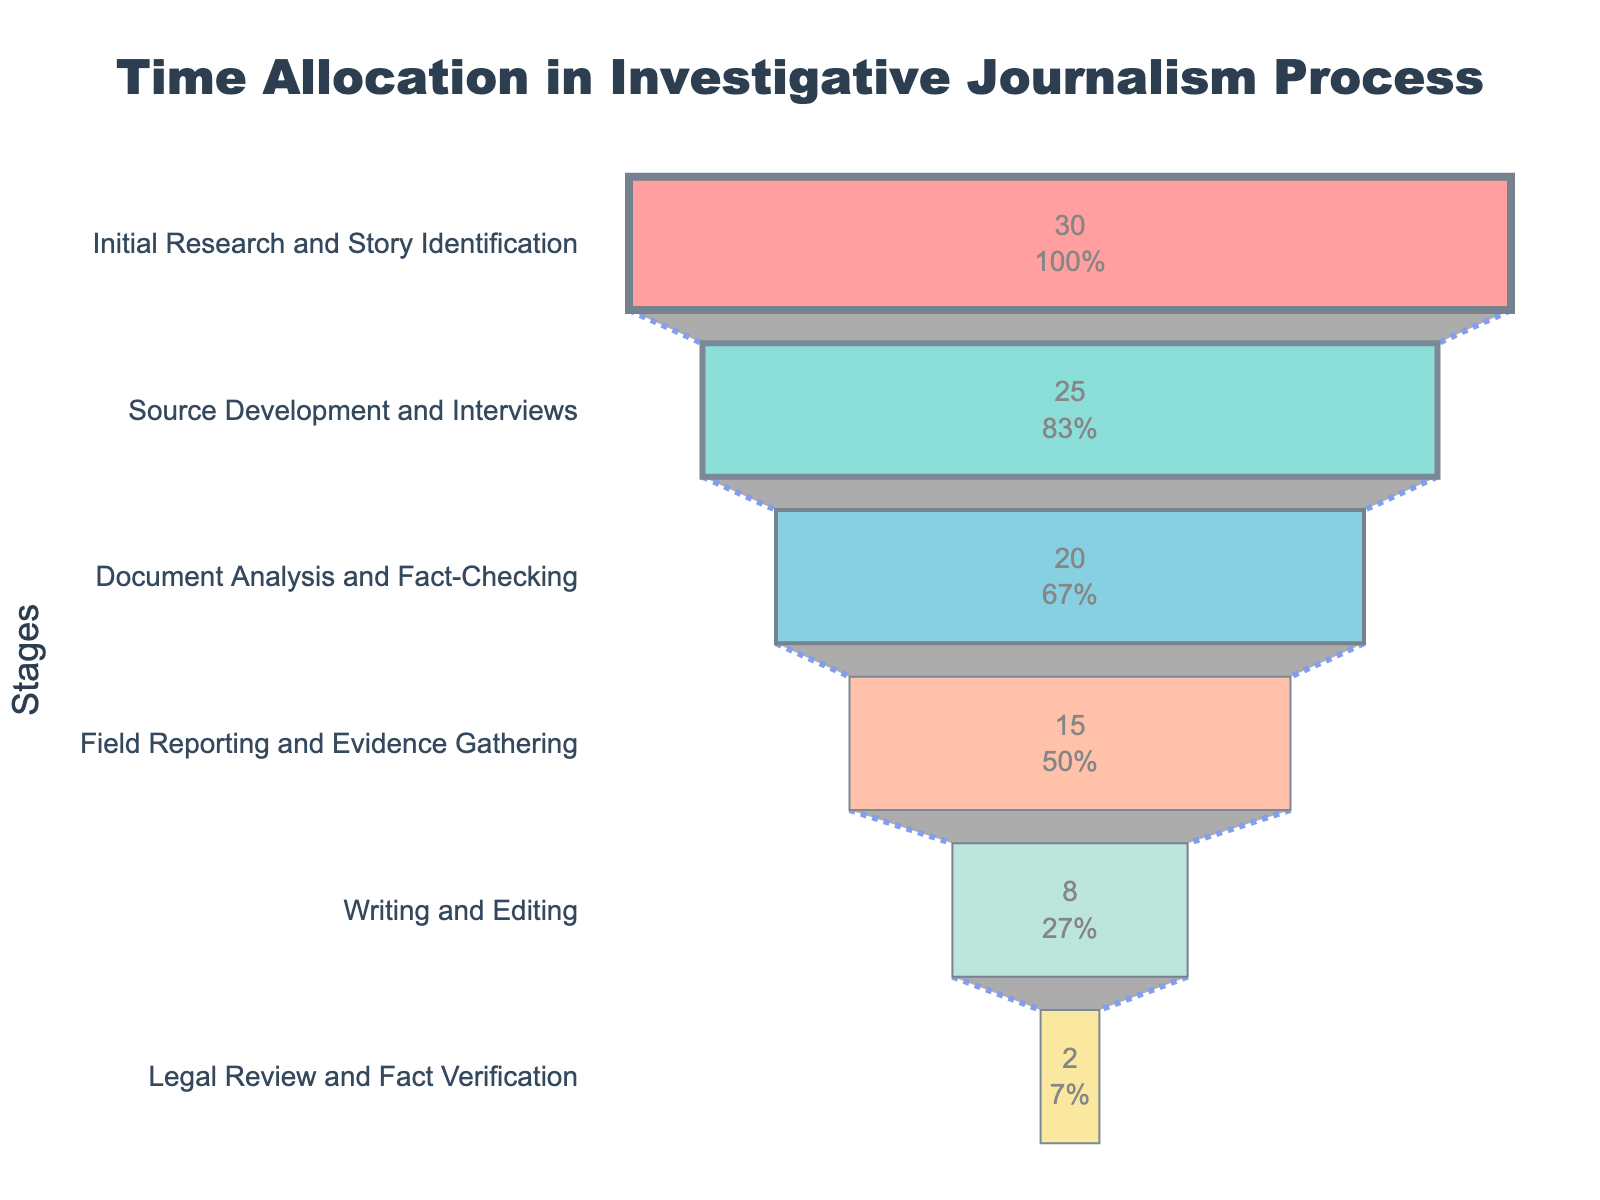What's the title of the funnel chart? The title is usually displayed at the top of the chart and helps describe the overall theme or subject of the figure.
Answer: Time Allocation in Investigative Journalism Process Which stage requires the most time according to the chart? The stage with the highest percentage value on the funnel chart indicates the one that requires the most time.
Answer: Initial Research and Story Identification How much time is spent on Field Reporting and Evidence Gathering compared to Document Analysis and Fact-Checking? Locate the percentages for both stages, then compare them directly by subtracting the smaller value from the larger value. Document Analysis and Fact-Checking is 20%, and Field Reporting and Evidence Gathering is 15%. 20% - 15% = 5%.
Answer: 5% more on Document Analysis and Fact-Checking What percentage of time is dedicated to the last two stages combined? Add the percentages of Writing and Editing (8%) and Legal Review and Fact Verification (2%). 8% + 2% = 10%.
Answer: 10% How many stages are there in the investigative journalism process illustrated in this chart? Count the unique stages listed along the y-axis of the funnel chart.
Answer: 6 Which stage has the lowest percentage of time spent? Identify the stage with the smallest percentage value in the funnel chart.
Answer: Legal Review and Fact Verification Is more time spent on Source Development and Interviews or on Field Reporting and Evidence Gathering? Compare the percentages for Source Development and Interviews (25%) and Field Reporting and Evidence Gathering (15%). 25% > 15%.
Answer: Source Development and Interviews What's the difference in time allocation between Initial Research and Story Identification and Writing and Editing? Subtract the percentage value of Writing and Editing (8%) from Initial Research and Story Identification (30%). 30% - 8% = 22%.
Answer: 22% What visual element is used to connect the different stages in the funnel chart? Look for the connecting lines or visual cues that link each stage in the chart. In this chart, it is a line with a dot pattern.
Answer: Dotted line How does the time spent on Source Development and Interviews compare to the sum of Writing and Editing and Legal Review and Fact Verification? Calculate the sum of Writing and Editing (8%) and Legal Review and Fact Verification (2%), which equals 10%. Compare this to Source Development and Interviews (25%). 25% > 10%.
Answer: More time on Source Development and Interviews 